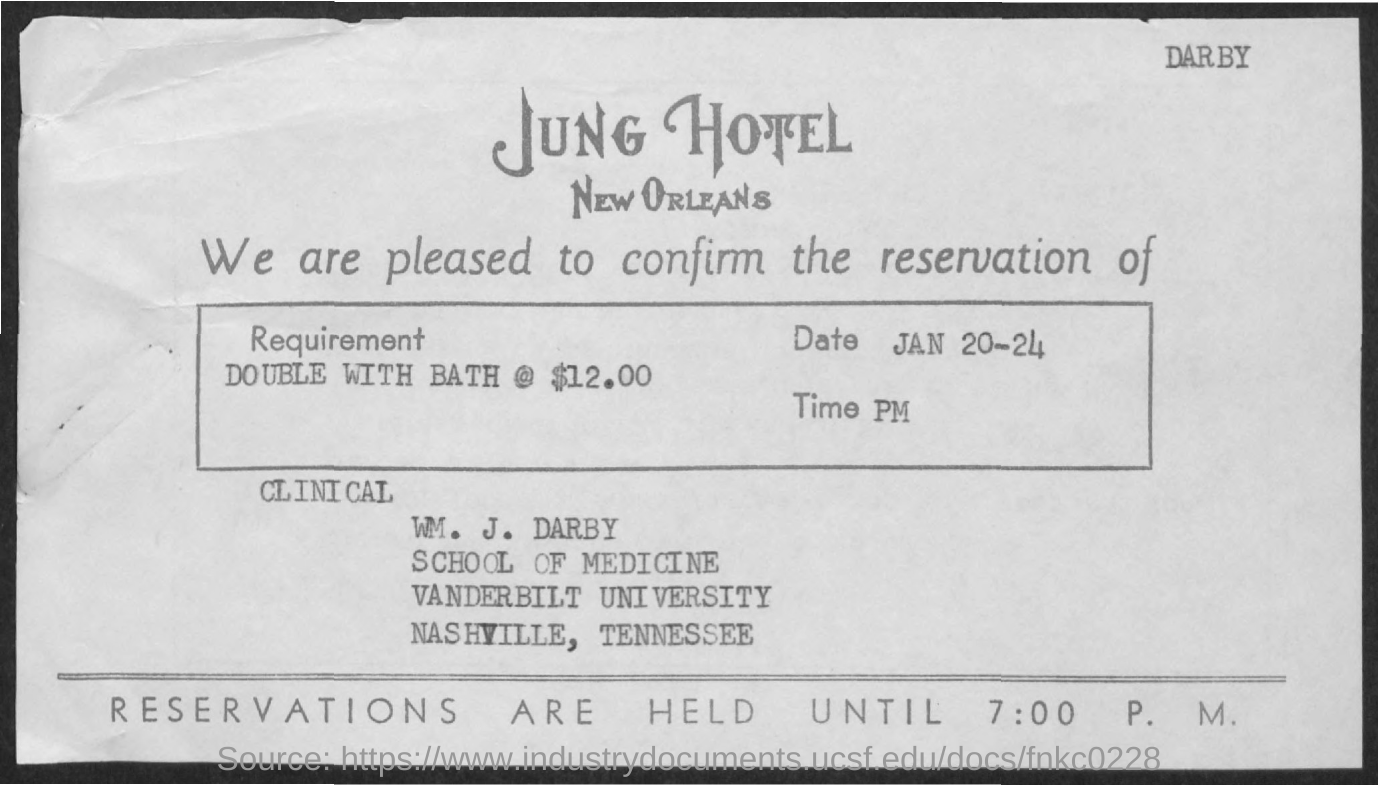Mention a couple of crucial points in this snapshot. The reservation is made at Jung Hotel. The letter is addressed to William J. Darby. The requirement is for a double room with a bath, priced at $12.00. The time is.. PM. The date range of January 20 to 24 inclusive is being referred to as "What is the Date? 